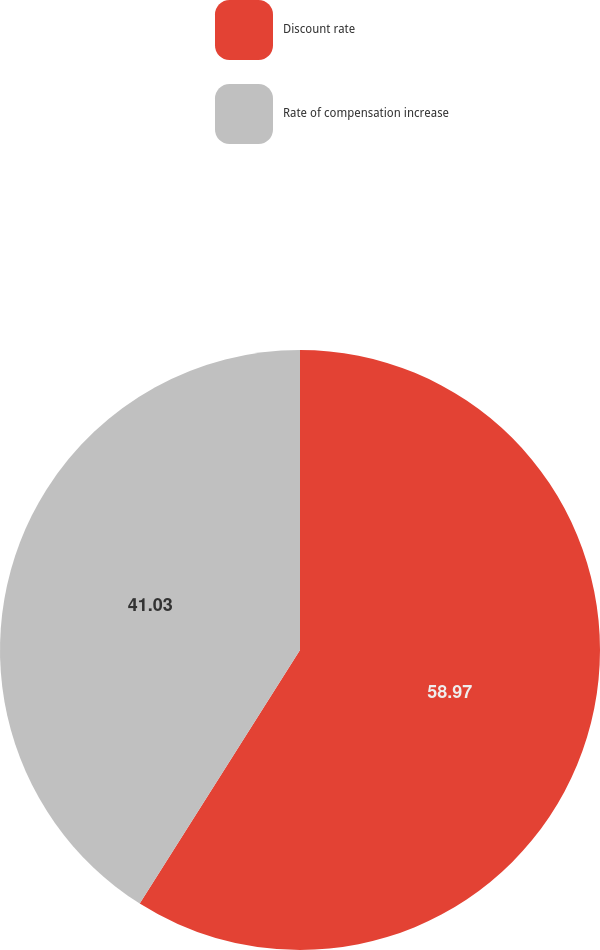Convert chart. <chart><loc_0><loc_0><loc_500><loc_500><pie_chart><fcel>Discount rate<fcel>Rate of compensation increase<nl><fcel>58.97%<fcel>41.03%<nl></chart> 